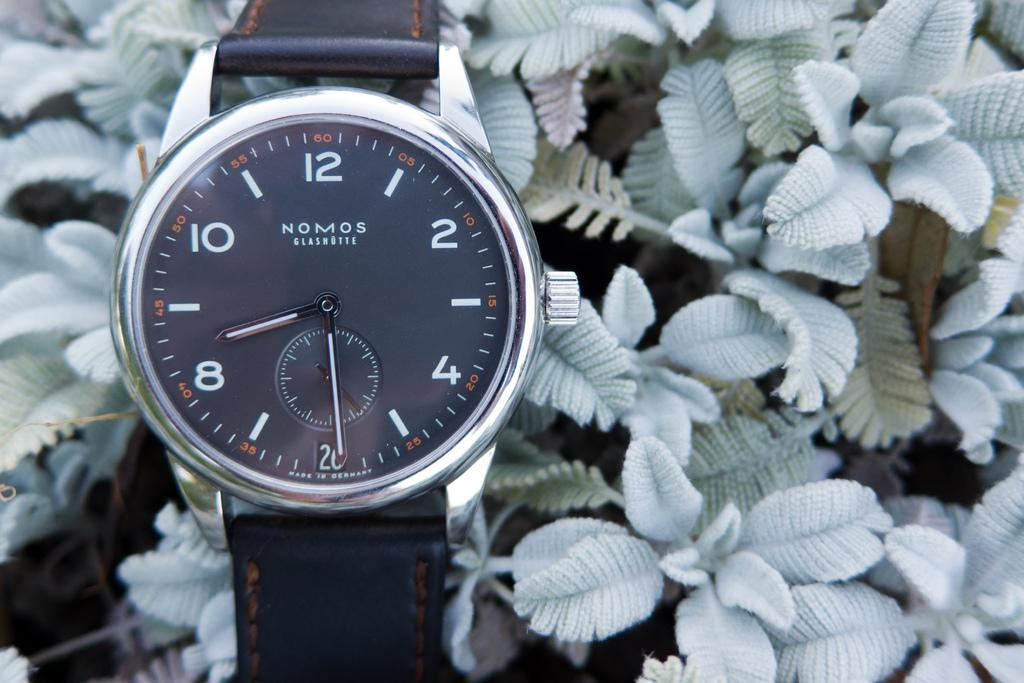<image>
Render a clear and concise summary of the photo. A Nomos brand watch is sitting over a bed of plant leaves. 